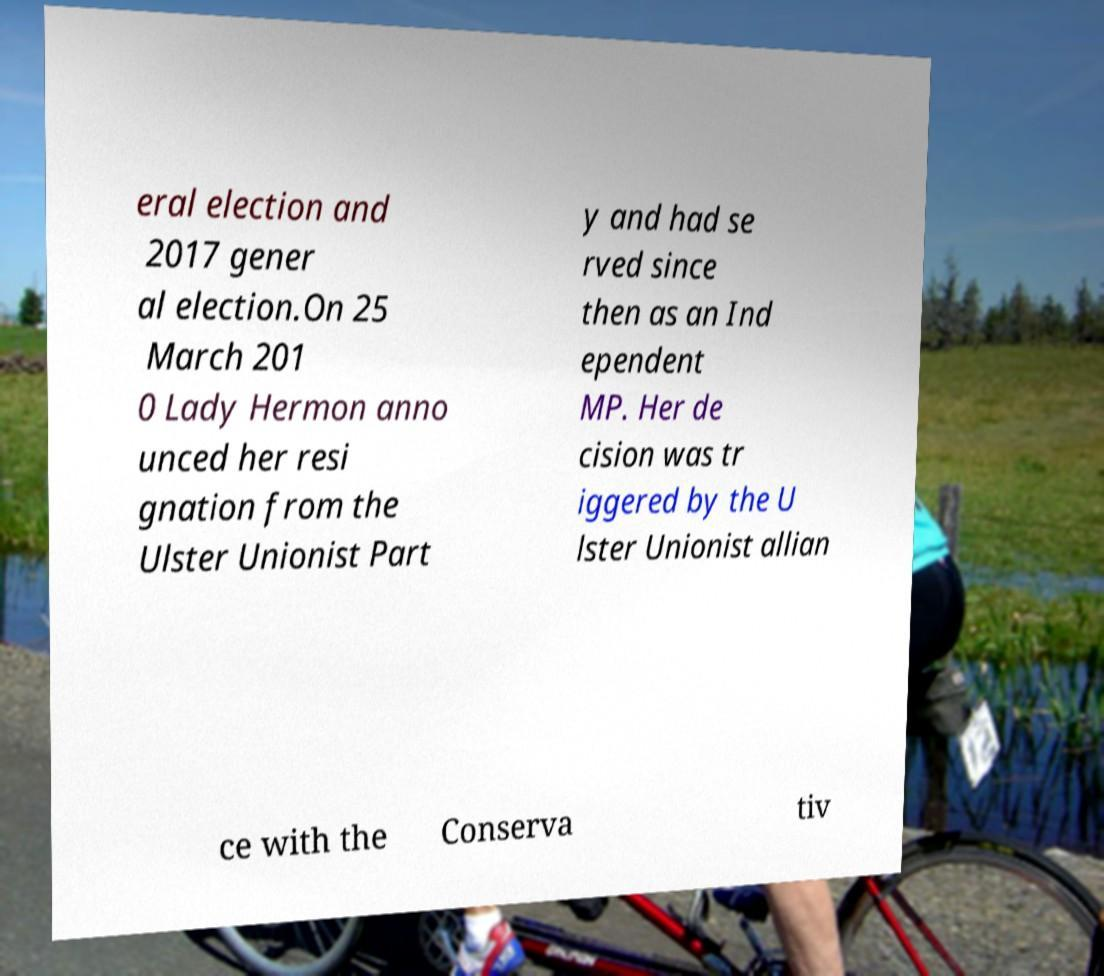Can you accurately transcribe the text from the provided image for me? eral election and 2017 gener al election.On 25 March 201 0 Lady Hermon anno unced her resi gnation from the Ulster Unionist Part y and had se rved since then as an Ind ependent MP. Her de cision was tr iggered by the U lster Unionist allian ce with the Conserva tiv 